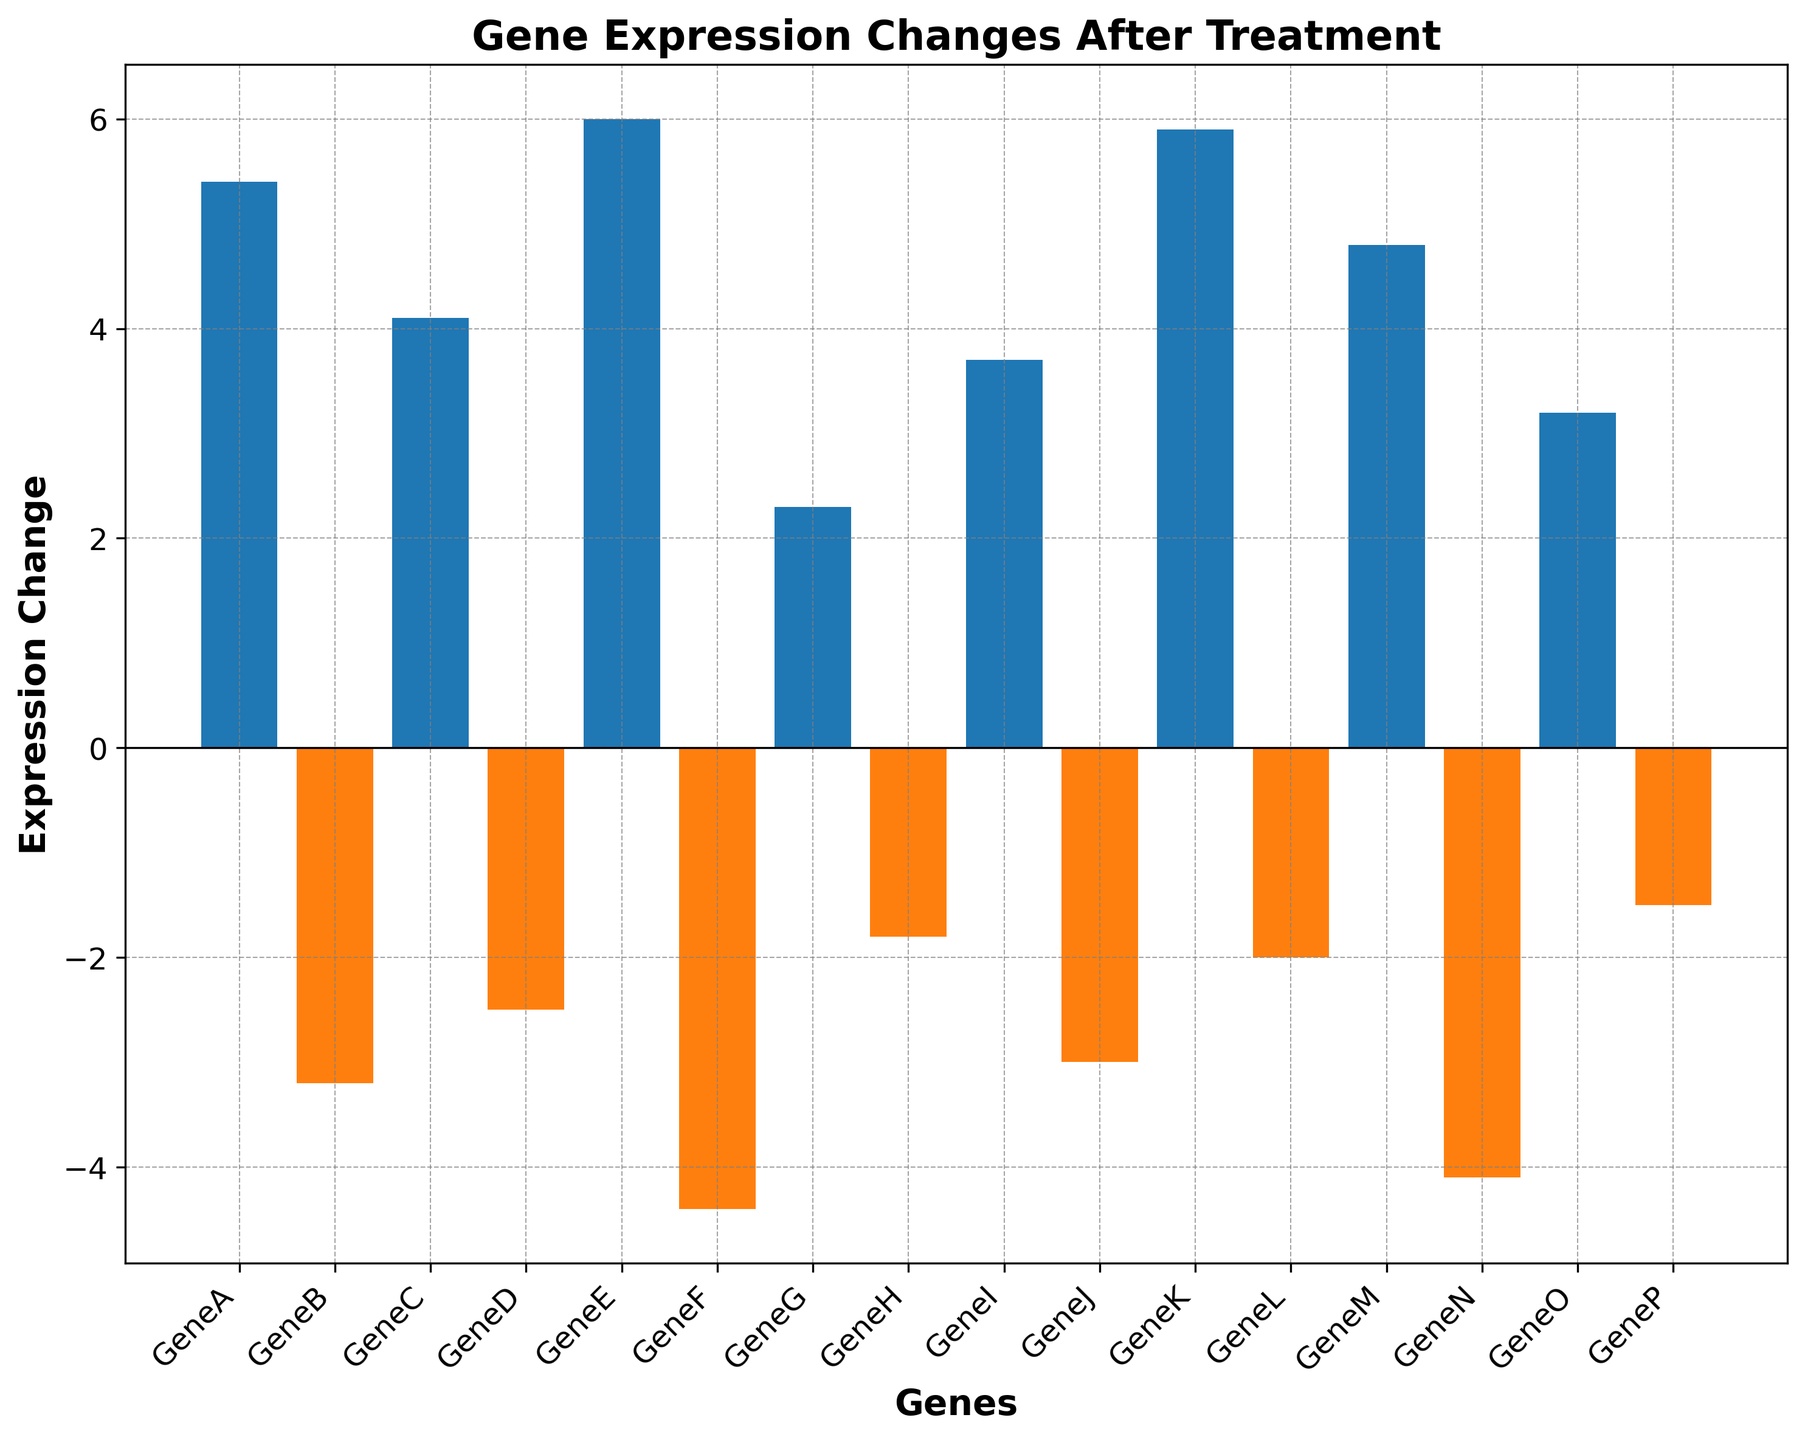Which gene shows the highest upregulation after treatment? By inspecting the height of the bars above the x-axis (positive values), we identify GeneE as having the tallest bar, indicating the highest upregulation.
Answer: GeneE Which gene exhibits the strongest downregulation after treatment? Observing the bars below the x-axis (negative values), we note that GeneF has the tallest bar, showing the strongest downregulation.
Answer: GeneF What is the average expression change for all genes? Sum all expression changes (5.4 + (-3.2) + 4.1 + (-2.5) + 6.0 + (-4.4) + 2.3 + (-1.8) + 3.7 + (-3.0) + 5.9 + (-2.0) + 4.8 + (-4.1) + 3.2 + (-1.5)) which equals 14.9, then divide by the number of genes (16), resulting in an average of 14.9/16 ≈ 0.93.
Answer: 0.93 How many genes exhibit downregulation after the treatment? Count the bars that are below the x-axis. The genes are GeneB, GeneD, GeneF, GeneH, GeneJ, GeneL, GeneN, and GeneP which sum to 8.
Answer: 8 Is the total upregulation higher than the total downregulation? Sum the positive changes (5.4 + 4.1 + 6.0 + 2.3 + 3.7 + 5.9 + 4.8 + 3.2 = 35.4) and sum the negative changes (-3.2 + (-2.5) + (-4.4) + (-1.8) + (-3.0) + (-2.0) + (-4.1) + (-1.5) = -22.5). Compare the two sums to see that the total upregulation (35.4) is greater than the total downregulation (-22.5).
Answer: Yes Which genes have an expression change greater than 4.0? Examine the bars above+4, identifying GeneA (5.4), GeneE (6.0), GeneK (5.9), and GeneM (4.8).
Answer: GeneA, GeneE, GeneK, GeneM What is the difference in expression change between GeneA and GeneF? Subtract the expression change of GeneF from GeneA (5.4 - (-4.4)) which results in 5.4 + 4.4 = 9.8.
Answer: 9.8 Which gene has the closest expression change to 0? Identify the bar with a height closest to the x-axis, which is GeneP with -1.5.
Answer: GeneP Which group of genes (upregulated or downregulated) has more members? Count the genes with positive changes (upregulated) and negative changes (downregulated). Upregulated: 8 genes; Downregulated: 8 genes. Since both counts are equal, it results in a tie.
Answer: Tie Is the sum of the expression changes for GeneA, GeneK, and GeneM greater than that of GeneF, GeneN, and GeneJ? Calculate the sum for GeneA, GeneK, and GeneM (5.4 + 5.9 + 4.8 = 16.1) and then for GeneF, GeneN, and GeneJ (-4.4 + (-4.1) + (-3.0) = -11.5). Compare 16.1 to -11.5, noting 16.1 is indeed greater.
Answer: Yes 